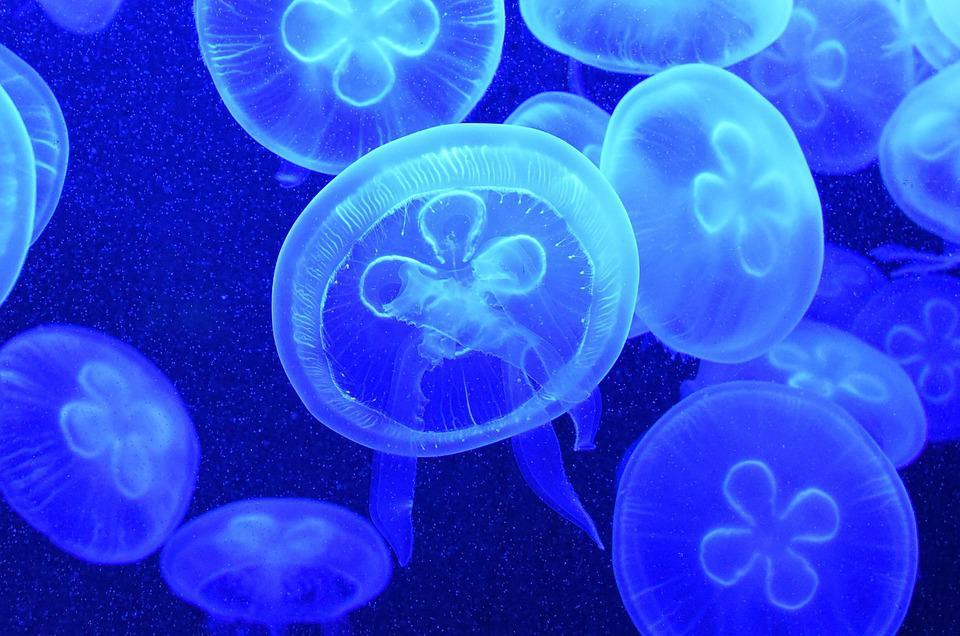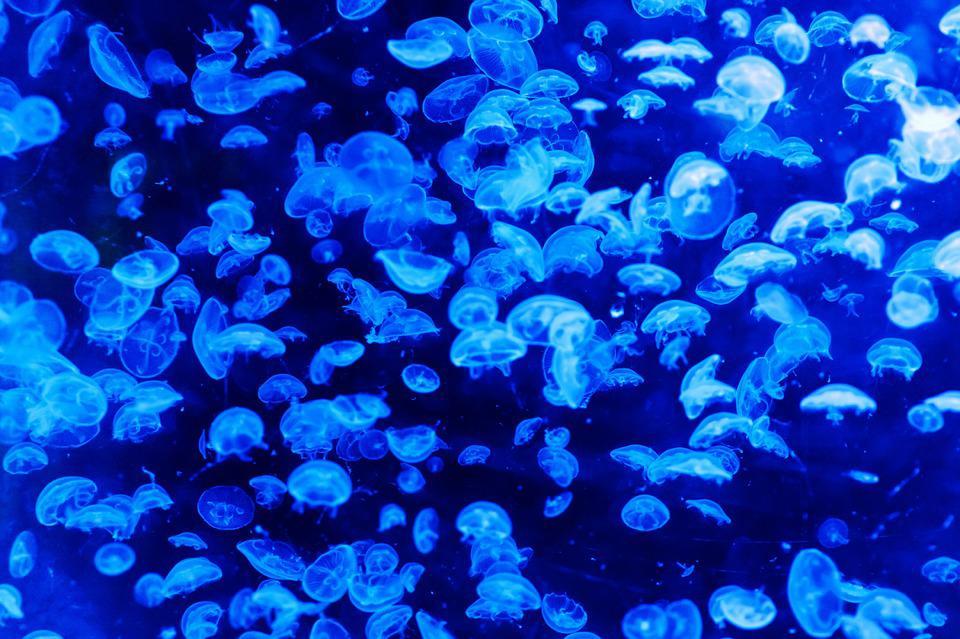The first image is the image on the left, the second image is the image on the right. Considering the images on both sides, is "There are pink jellyfish in the image on the left." valid? Answer yes or no. No. The first image is the image on the left, the second image is the image on the right. Given the left and right images, does the statement "In one of the images, there are warm colored jellyfish" hold true? Answer yes or no. No. 